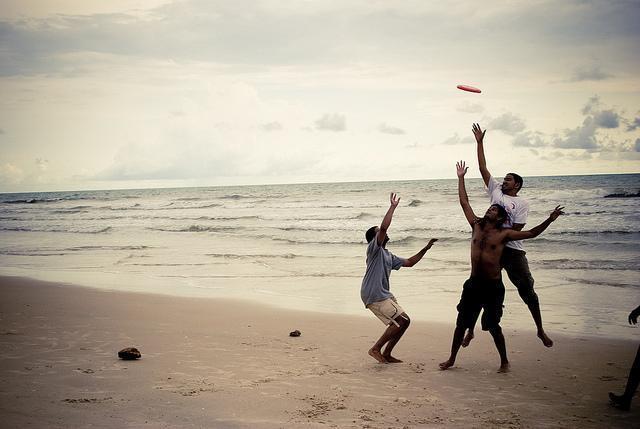How many people are in this photo?
Give a very brief answer. 3. How many people are there?
Give a very brief answer. 2. 